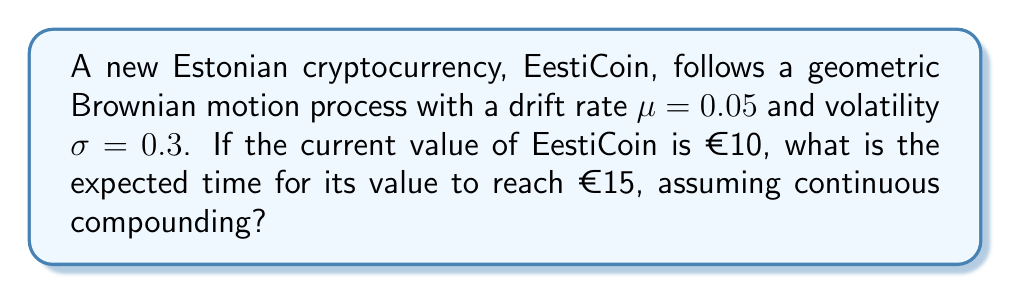Give your solution to this math problem. To solve this problem, we'll use the properties of geometric Brownian motion and the concept of first passage time.

Step 1: Identify the parameters
- Initial value: $S_0 = €10$
- Target value: $S_T = €15$
- Drift rate: $\mu = 0.05$
- Volatility: $\sigma = 0.3$

Step 2: Calculate the expected time using the first passage time formula for geometric Brownian motion
The expected time $E[T]$ for a geometric Brownian motion process to reach a certain threshold is given by:

$$E[T] = \frac{\ln(S_T/S_0) - (\mu - \frac{\sigma^2}{2})T}{\mu - \frac{\sigma^2}{2}}$$

Step 3: Substitute the values into the formula
$$E[T] = \frac{\ln(15/10) - (0.05 - \frac{0.3^2}{2})T}{0.05 - \frac{0.3^2}{2}}$$

Step 4: Simplify
$$E[T] = \frac{\ln(1.5) - (0.05 - 0.045)T}{0.05 - 0.045}$$
$$E[T] = \frac{0.4055 - 0.005T}{0.005}$$

Step 5: Solve for T
$$0.4055 - 0.005T = 0.005T$$
$$0.4055 = 0.01T$$
$$T = 40.55$$

Therefore, the expected time for EestiCoin to reach €15 is approximately 40.55 years.
Answer: 40.55 years 